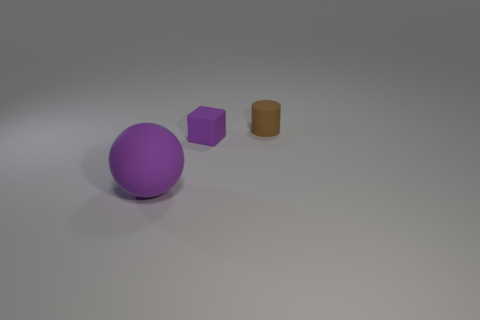Add 1 big rubber spheres. How many objects exist? 4 Subtract all blocks. How many objects are left? 2 Add 1 small purple cubes. How many small purple cubes are left? 2 Add 1 large brown metal things. How many large brown metal things exist? 1 Subtract 0 brown cubes. How many objects are left? 3 Subtract all small brown things. Subtract all big rubber objects. How many objects are left? 1 